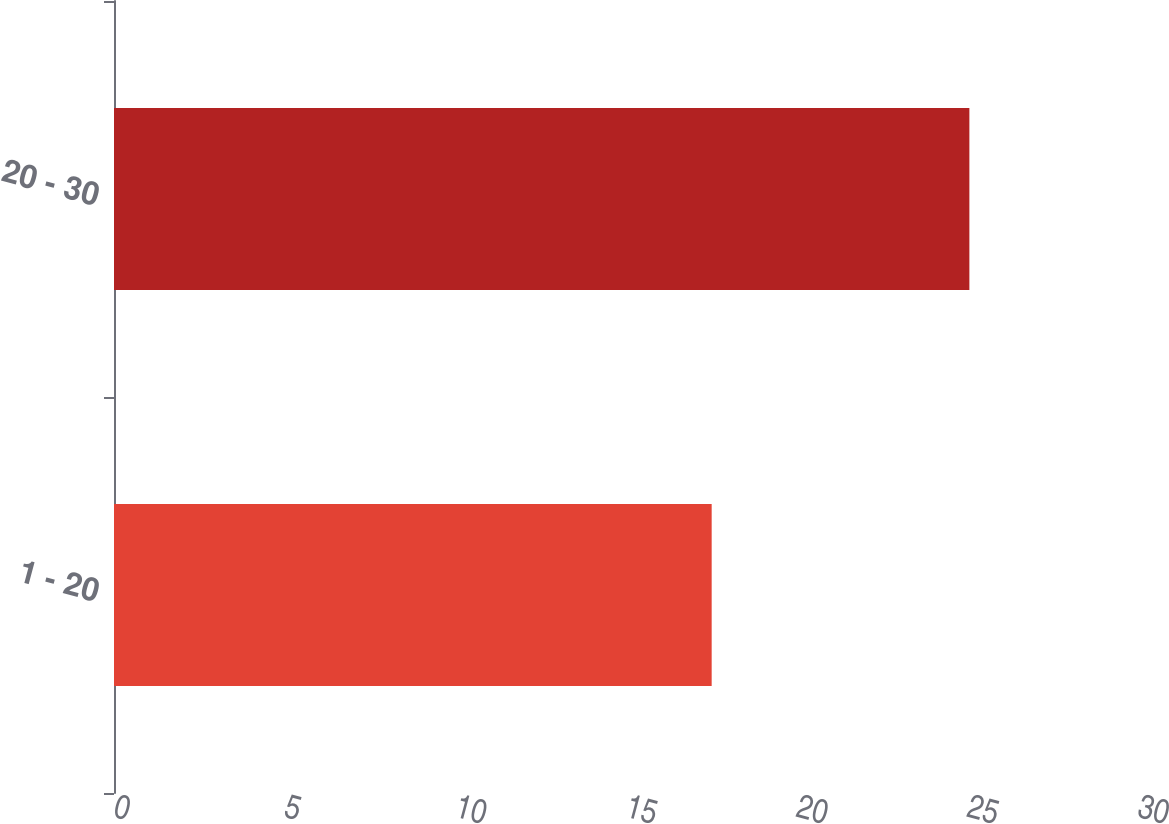Convert chart. <chart><loc_0><loc_0><loc_500><loc_500><bar_chart><fcel>1 - 20<fcel>20 - 30<nl><fcel>17.51<fcel>25.06<nl></chart> 